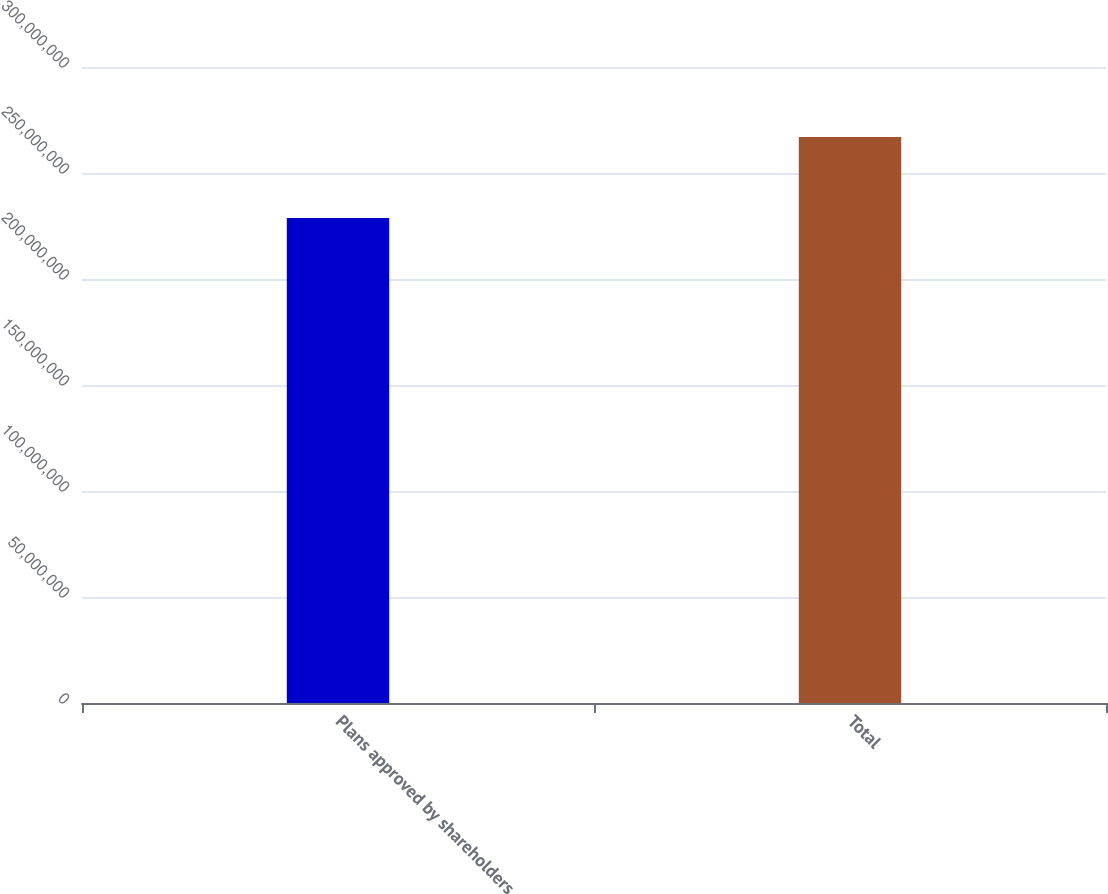<chart> <loc_0><loc_0><loc_500><loc_500><bar_chart><fcel>Plans approved by shareholders<fcel>Total<nl><fcel>2.28771e+08<fcel>2.67035e+08<nl></chart> 